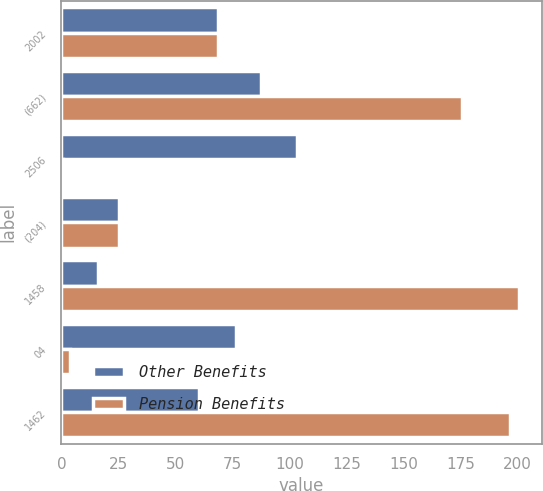<chart> <loc_0><loc_0><loc_500><loc_500><stacked_bar_chart><ecel><fcel>2002<fcel>(662)<fcel>2506<fcel>(204)<fcel>1458<fcel>04<fcel>1462<nl><fcel>Other Benefits<fcel>68.6<fcel>87.6<fcel>103.2<fcel>25.3<fcel>16.2<fcel>76.7<fcel>60.5<nl><fcel>Pension Benefits<fcel>68.6<fcel>175.8<fcel>0.7<fcel>25.5<fcel>200.6<fcel>3.8<fcel>196.8<nl></chart> 